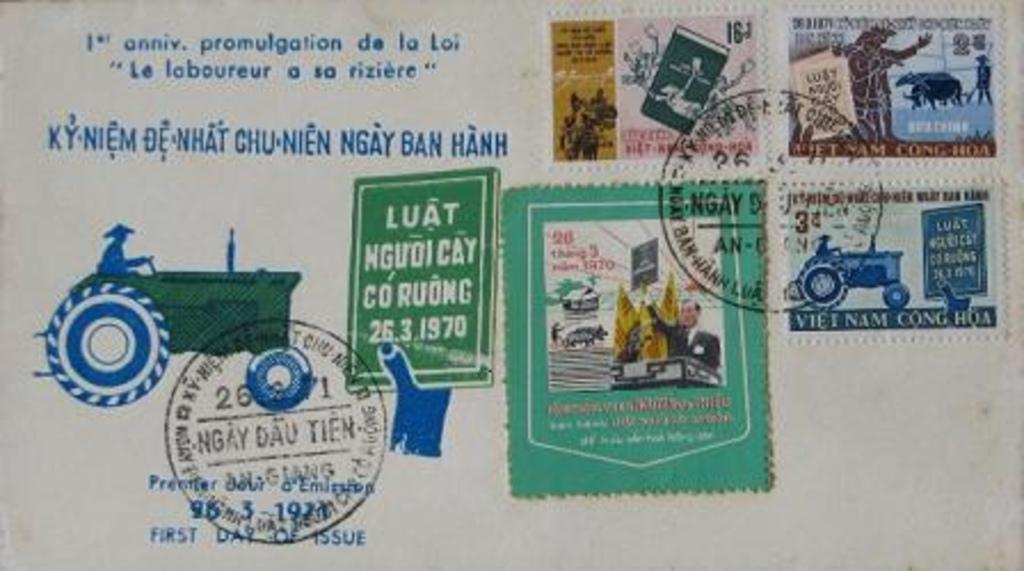Please provide a concise description of this image. In this image there is a post card, on that card there is some text and stamps and there is tractor image. 